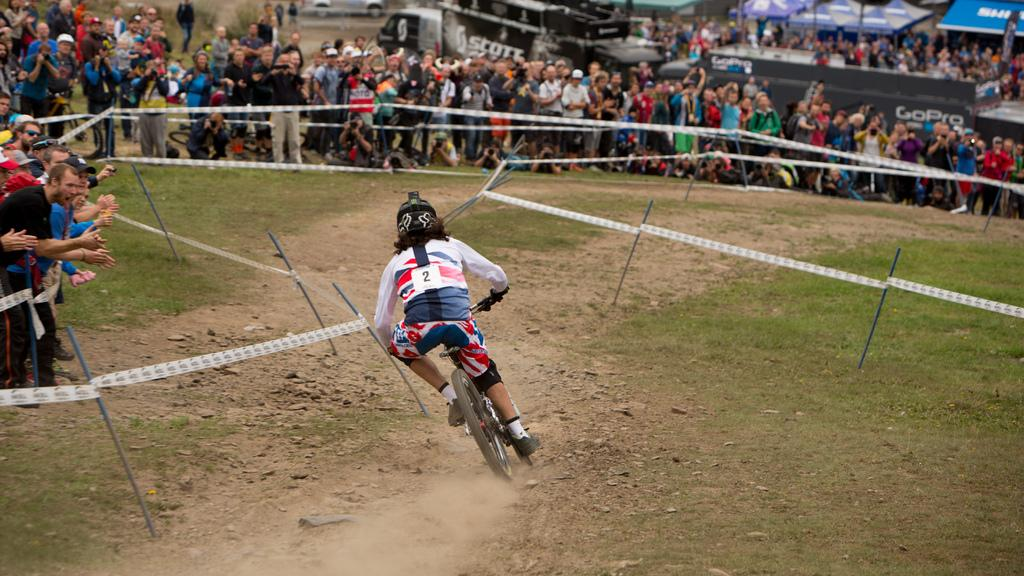<image>
Write a terse but informative summary of the picture. Person in a race on a bike with a number 2 on their backs. 